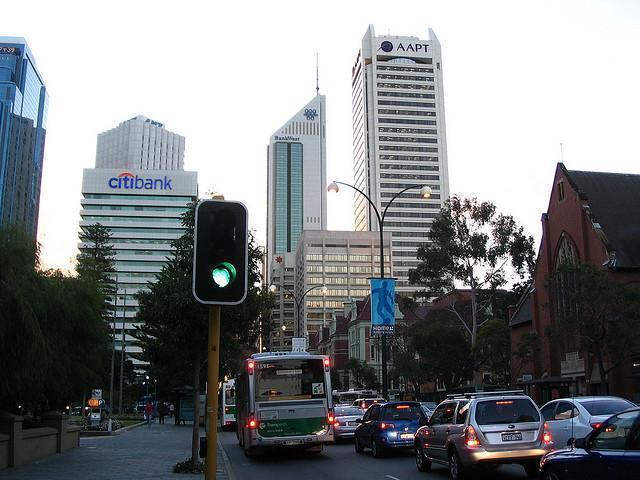Who designed the first building's logo?
Choose the correct response and explain in the format: 'Answer: answer
Rationale: rationale.'
Options: Maurice finn, doug thomas, beth finkelstein, paula scher. Answer: paula scher.
Rationale: That is the designer of the logo. 